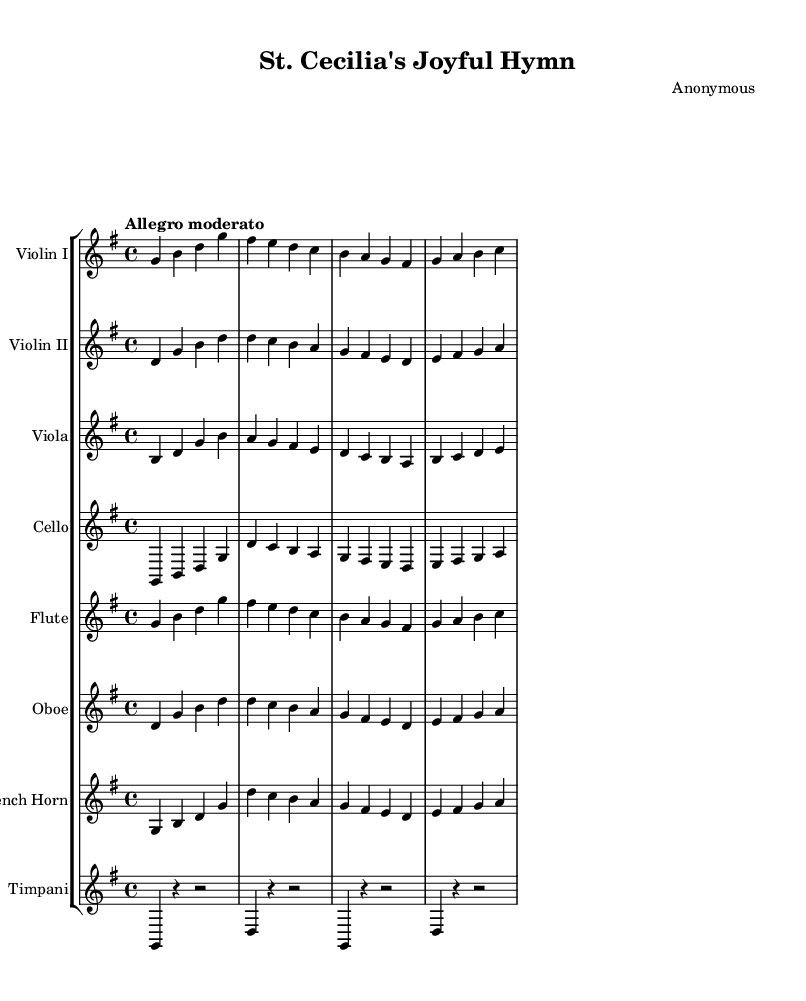What is the key signature of this music? The key signature shown in the music is G major, which has one sharp (F#). You can tell this by looking at the key signature at the beginning of the sheet music, which indicates that the piece is in G major.
Answer: G major What is the time signature of this music? The time signature displayed is 4/4. This can be identified by looking at the fraction notation at the beginning of the sheet music, which tells us there are four beats per measure, and the quarter note gets one beat.
Answer: 4/4 What is the tempo marking of this piece? The tempo marking indicated in the score is "Allegro moderato." This instruction, found at the start of the piece, suggests a moderately fast tempo, guiding how the piece should be played.
Answer: Allegro moderato How many instrumental parts are there in total? The music features a total of eight parts, including two violins, a viola, a cello, a flute, an oboe, a French horn, and timpani. Each part is represented as a separate staff in the score, allowing different musicians to play together.
Answer: Eight Which instrument plays the same melody as Violin I? The flute plays the same melody as Violin I. By comparing the notes of Violin I and the flute parts, you can see they have the same melodic line.
Answer: Flute What type of musical piece is "St. Cecilia's Joyful Hymn"? This piece can be categorized as a celebratory orchestral work that honors St. Cecilia, known as the patron saint of musicians. The joyful and uplifting nature of the music aligns with the theme of celebrating a saint.
Answer: Orchestral What is the first note of the cello part? The first note of the cello part is G. Observing the cello staff, you can see that it begins on the note G in the first measure, indicating this is the starting pitch for that instrument.
Answer: G 